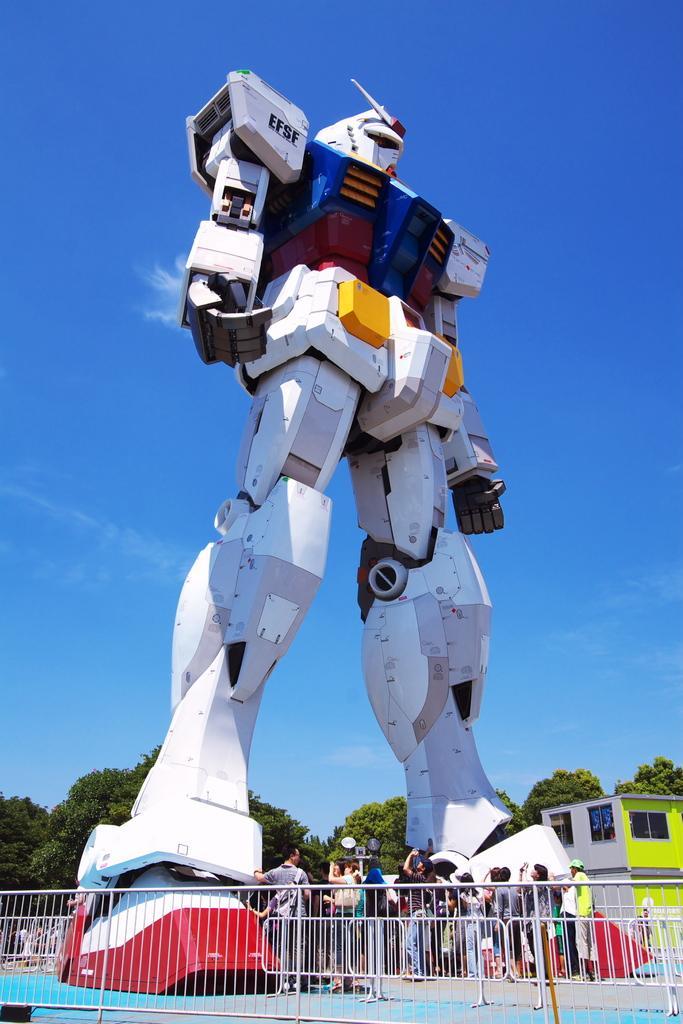Please provide a concise description of this image. In this picture we can see a robot. On the ground there is a group of people. At the bottom of the image, there are grilles. Behind the robot, there is a building, trees and the sky. 